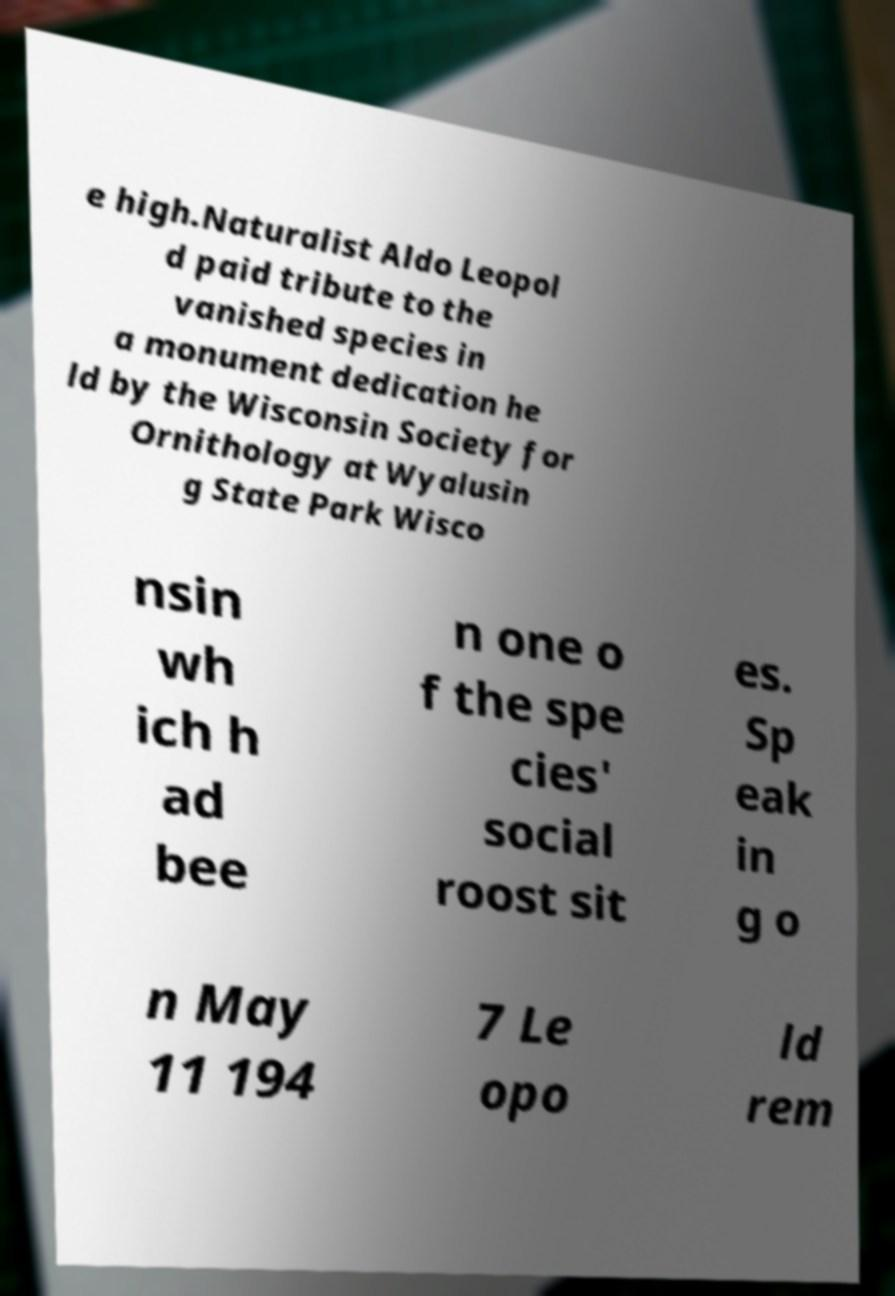What messages or text are displayed in this image? I need them in a readable, typed format. e high.Naturalist Aldo Leopol d paid tribute to the vanished species in a monument dedication he ld by the Wisconsin Society for Ornithology at Wyalusin g State Park Wisco nsin wh ich h ad bee n one o f the spe cies' social roost sit es. Sp eak in g o n May 11 194 7 Le opo ld rem 